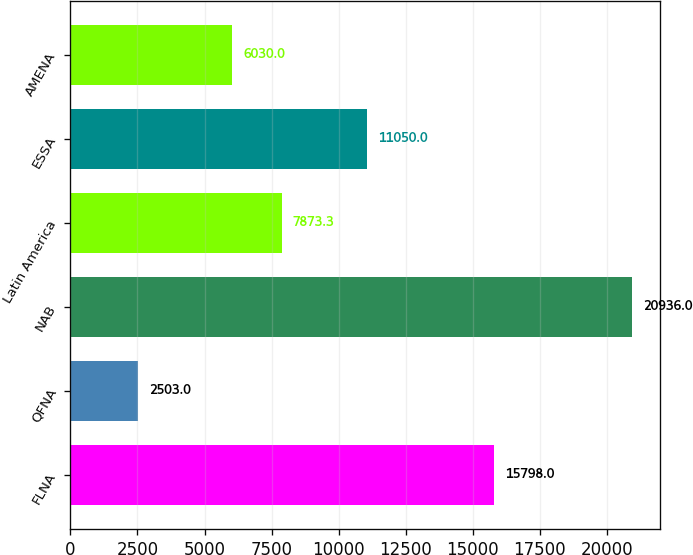Convert chart to OTSL. <chart><loc_0><loc_0><loc_500><loc_500><bar_chart><fcel>FLNA<fcel>QFNA<fcel>NAB<fcel>Latin America<fcel>ESSA<fcel>AMENA<nl><fcel>15798<fcel>2503<fcel>20936<fcel>7873.3<fcel>11050<fcel>6030<nl></chart> 